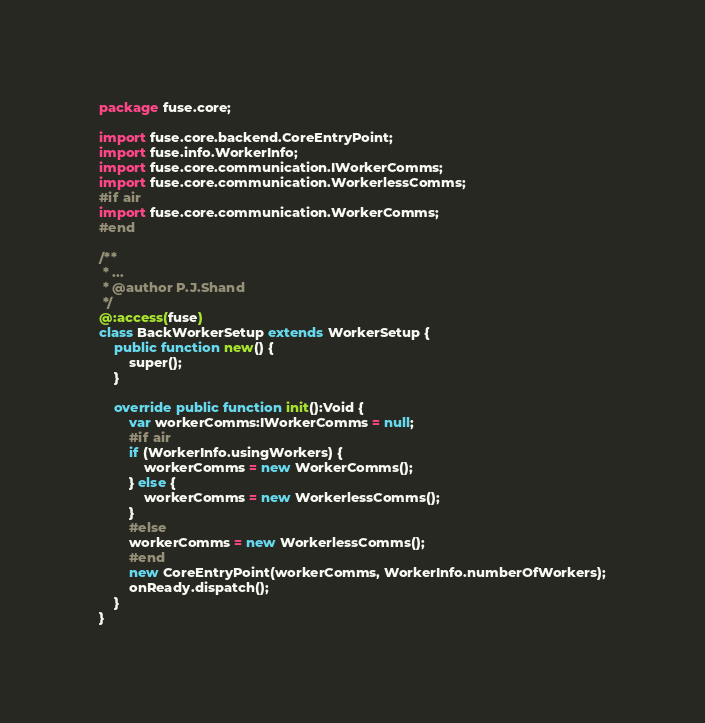Convert code to text. <code><loc_0><loc_0><loc_500><loc_500><_Haxe_>package fuse.core;

import fuse.core.backend.CoreEntryPoint;
import fuse.info.WorkerInfo;
import fuse.core.communication.IWorkerComms;
import fuse.core.communication.WorkerlessComms;
#if air
import fuse.core.communication.WorkerComms;
#end

/**
 * ...
 * @author P.J.Shand
 */
@:access(fuse)
class BackWorkerSetup extends WorkerSetup {
	public function new() {
		super();
	}

	override public function init():Void {
		var workerComms:IWorkerComms = null;
		#if air
		if (WorkerInfo.usingWorkers) {
			workerComms = new WorkerComms();
		} else {
			workerComms = new WorkerlessComms();
		}
		#else
		workerComms = new WorkerlessComms();
		#end
		new CoreEntryPoint(workerComms, WorkerInfo.numberOfWorkers);
		onReady.dispatch();
	}
}
</code> 